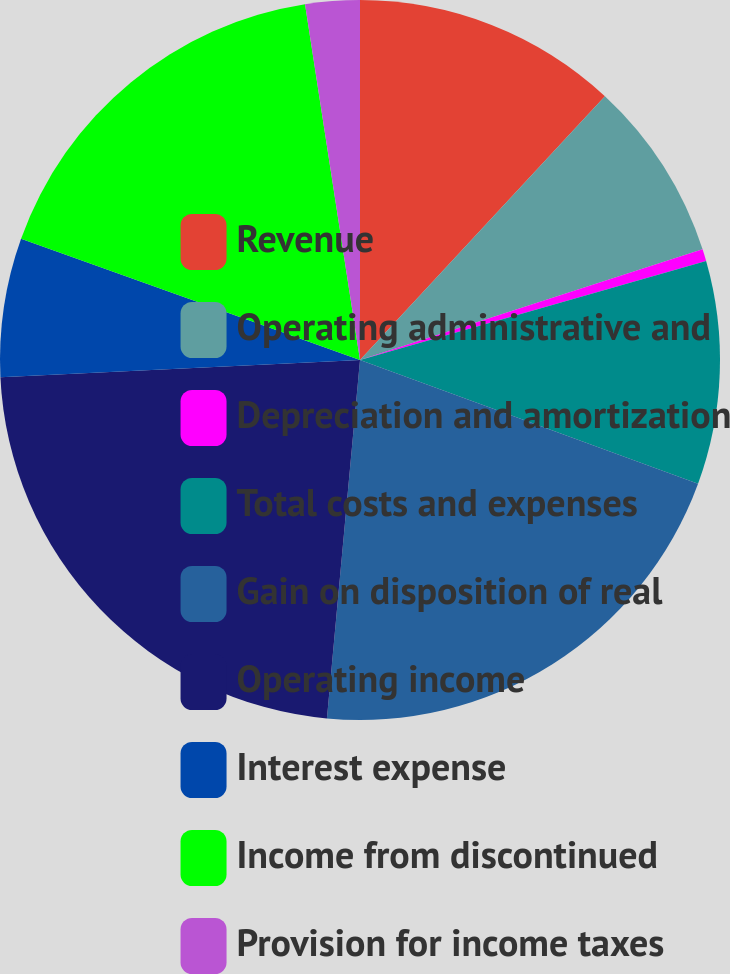Convert chart to OTSL. <chart><loc_0><loc_0><loc_500><loc_500><pie_chart><fcel>Revenue<fcel>Operating administrative and<fcel>Depreciation and amortization<fcel>Total costs and expenses<fcel>Gain on disposition of real<fcel>Operating income<fcel>Interest expense<fcel>Income from discontinued<fcel>Provision for income taxes<nl><fcel>11.91%<fcel>8.12%<fcel>0.54%<fcel>10.02%<fcel>20.88%<fcel>22.78%<fcel>6.23%<fcel>17.09%<fcel>2.44%<nl></chart> 